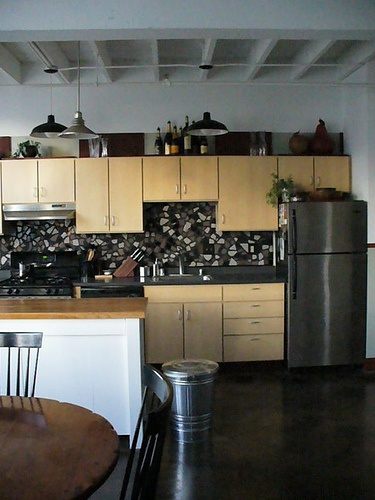Describe the objects in this image and their specific colors. I can see refrigerator in gray and black tones, dining table in gray, maroon, and black tones, chair in gray, black, and darkgray tones, oven in gray and black tones, and chair in gray, lightgray, black, and darkgray tones in this image. 